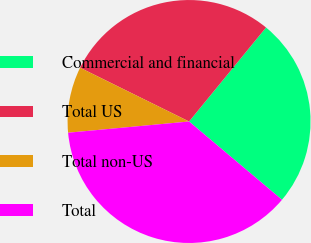<chart> <loc_0><loc_0><loc_500><loc_500><pie_chart><fcel>Commercial and financial<fcel>Total US<fcel>Total non-US<fcel>Total<nl><fcel>25.22%<fcel>28.62%<fcel>8.77%<fcel>37.39%<nl></chart> 